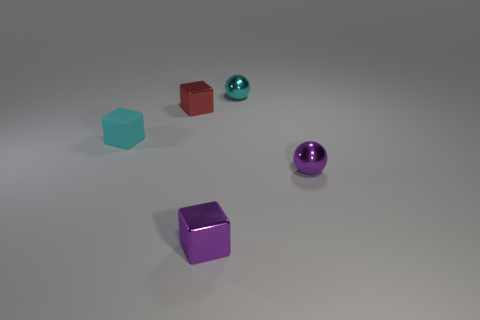Add 1 tiny red metal cubes. How many objects exist? 6 Subtract all cubes. How many objects are left? 2 Add 3 red metallic blocks. How many red metallic blocks exist? 4 Subtract 0 gray cylinders. How many objects are left? 5 Subtract all cyan things. Subtract all tiny purple metallic blocks. How many objects are left? 2 Add 5 tiny red shiny things. How many tiny red shiny things are left? 6 